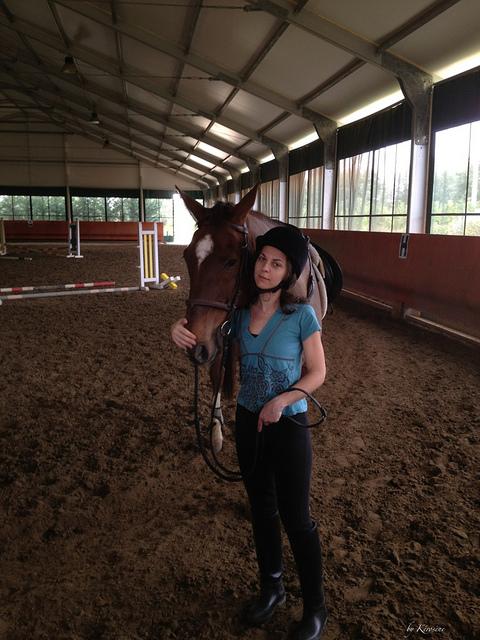Is the woman in this photo wearing an equestrian helmet?
Quick response, please. Yes. How many people are blurry?
Short answer required. 0. How many animals are there?
Write a very short answer. 1. What color is her blouse?
Short answer required. Blue. What city is the person in?
Be succinct. Dallas. 